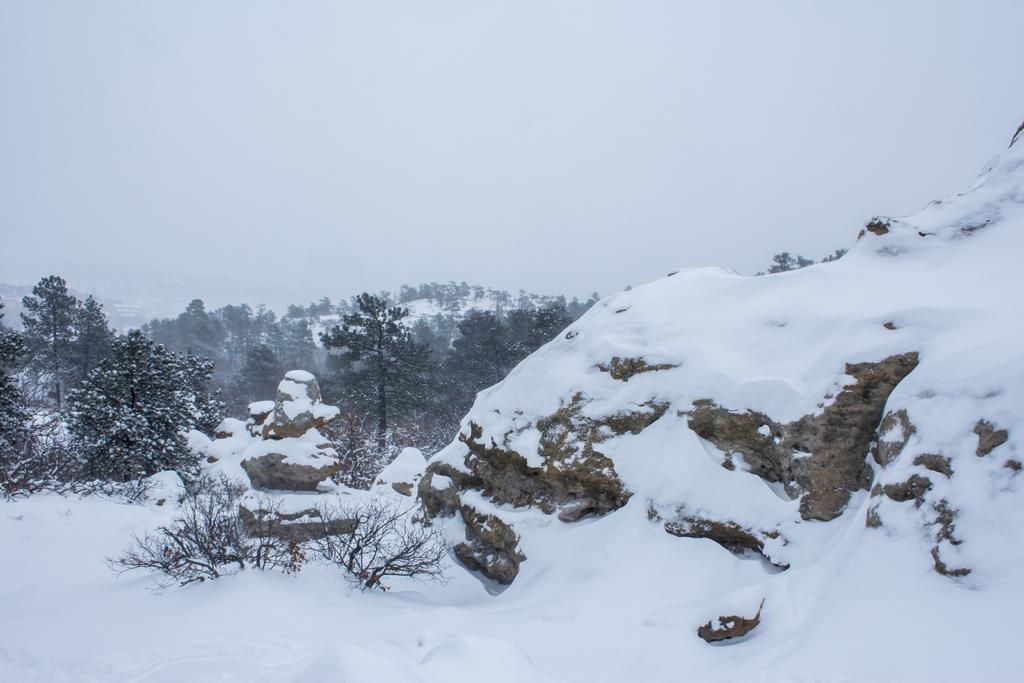What type of weather condition is depicted in the image? There is snow in the image, indicating a cold or wintry weather condition. What type of vegetation can be seen in the image? There are plants and trees in the image. What is visible at the top of the image? The sky is visible at the top of the image. What type of hair can be seen on the plants in the image? There is no hair present on the plants in the image; they are not animals or humans. 